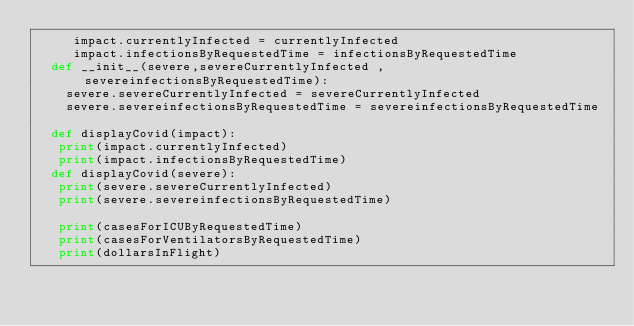<code> <loc_0><loc_0><loc_500><loc_500><_Python_>     impact.currentlyInfected = currentlyInfected
     impact.infectionsByRequestedTime = infectionsByRequestedTime
  def __init__(severe,severeCurrentlyInfected , severeinfectionsByRequestedTime):
    severe.severeCurrentlyInfected = severeCurrentlyInfected
    severe.severeinfectionsByRequestedTime = severeinfectionsByRequestedTime
     
  def displayCovid(impact):
   print(impact.currentlyInfected)
   print(impact.infectionsByRequestedTime)
  def displayCovid(severe):
   print(severe.severeCurrentlyInfected)
   print(severe.severeinfectionsByRequestedTime)
  
   print(casesForICUByRequestedTime)
   print(casesForVentilatorsByRequestedTime)
   print(dollarsInFlight)
</code> 